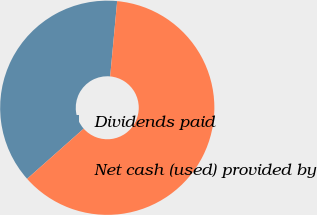Convert chart. <chart><loc_0><loc_0><loc_500><loc_500><pie_chart><fcel>Dividends paid<fcel>Net cash (used) provided by<nl><fcel>38.02%<fcel>61.98%<nl></chart> 